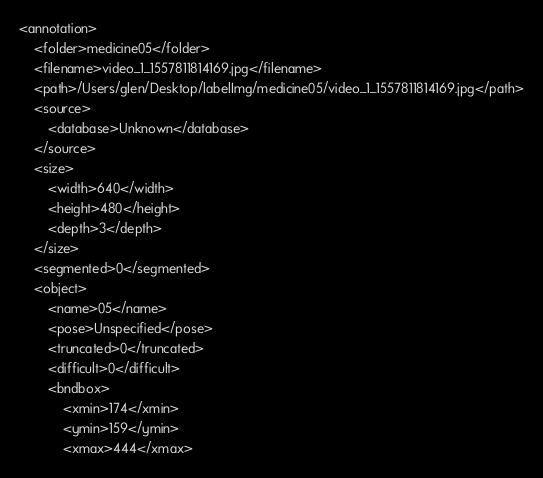<code> <loc_0><loc_0><loc_500><loc_500><_XML_><annotation>
	<folder>medicine05</folder>
	<filename>video_1_1557811814169.jpg</filename>
	<path>/Users/glen/Desktop/labelImg/medicine05/video_1_1557811814169.jpg</path>
	<source>
		<database>Unknown</database>
	</source>
	<size>
		<width>640</width>
		<height>480</height>
		<depth>3</depth>
	</size>
	<segmented>0</segmented>
	<object>
		<name>05</name>
		<pose>Unspecified</pose>
		<truncated>0</truncated>
		<difficult>0</difficult>
		<bndbox>
			<xmin>174</xmin>
			<ymin>159</ymin>
			<xmax>444</xmax></code> 